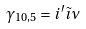<formula> <loc_0><loc_0><loc_500><loc_500>\gamma _ { 1 0 , 5 } = i ^ { \prime } \tilde { \imath } \nu</formula> 